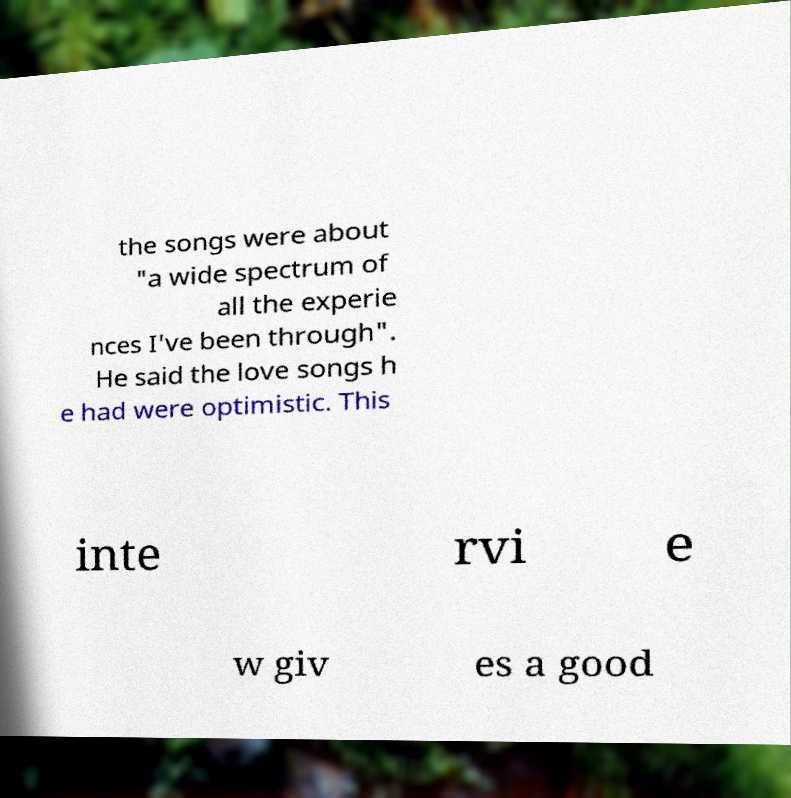Please identify and transcribe the text found in this image. the songs were about "a wide spectrum of all the experie nces I've been through". He said the love songs h e had were optimistic. This inte rvi e w giv es a good 